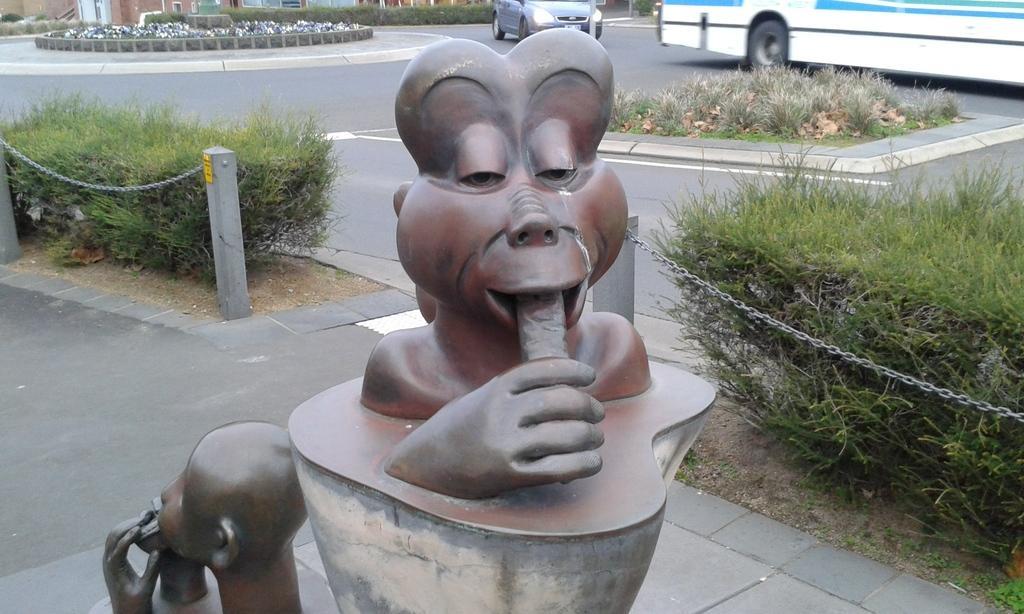How would you summarize this image in a sentence or two? In this image in the center there is a statue, and on the right side and left side there are some plants, chain, poles. And in the background there are some buildings and some vehicles and also there are some plants and grass, and at the bottom there is a road. 